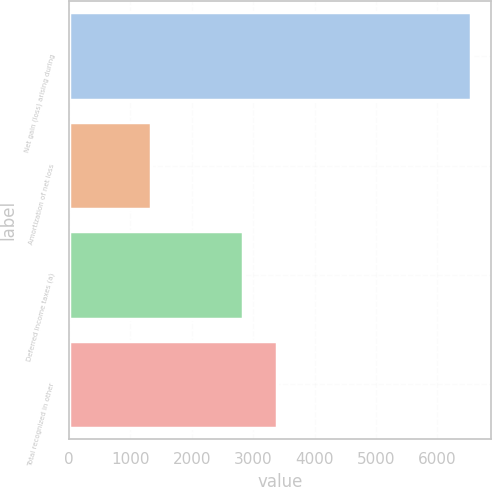Convert chart to OTSL. <chart><loc_0><loc_0><loc_500><loc_500><bar_chart><fcel>Net gain (loss) arising during<fcel>Amortization of net loss<fcel>Deferred income taxes (a)<fcel>Total recognized in other<nl><fcel>6545<fcel>1338<fcel>2831<fcel>3390<nl></chart> 